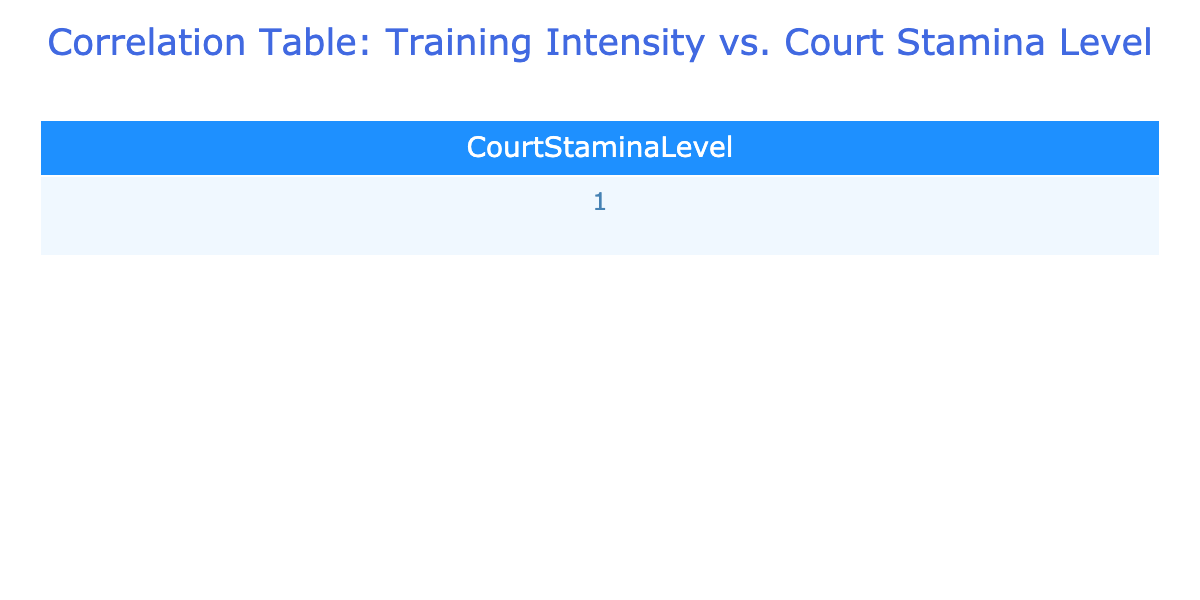What is the Court Stamina Level when Training Intensity is High? There are three data points in the "High" training intensity category: 90, 85, and 88. The table directly shows their values, hence the Court Stamina Levels for High are 90, 85, and 88.
Answer: 90, 85, 88 Which Training Intensity category has the lowest average Court Stamina Level? To find the average for each category: Low: (60 + 55 + 65) / 3 = 60, Medium: (75 + 72 + 78) / 3 = 75, High: (90 + 85 + 88) / 3 = 87.67. The lowest average is for Low, which is 60.
Answer: Low Is there any correlation between Medium and High Training Intensity? The correlation table shows that both categories have positive relationships with Court Stamina Level, but comparing them requires further detail which is not directly on the table. However, since they both lead to higher stamina, the general correlation can be considered positive.
Answer: Yes What is the total of the Court Stamina Levels for Low Training Intensity? The Court Stamina Levels for the Low category are 60, 55, and 65. Adding these values gives us 60 + 55 + 65 = 180, which represents the total Court Stamina Level for the Low intensity group.
Answer: 180 How does the average stamina level of the High intensity compare to Medium intensity? The average for High is 87.67, and for Medium is 75. The difference is calculated as 87.67 - 75 = 12.67, indicating that High intensity has a significantly higher average stamina level compared to Medium.
Answer: 12.67 